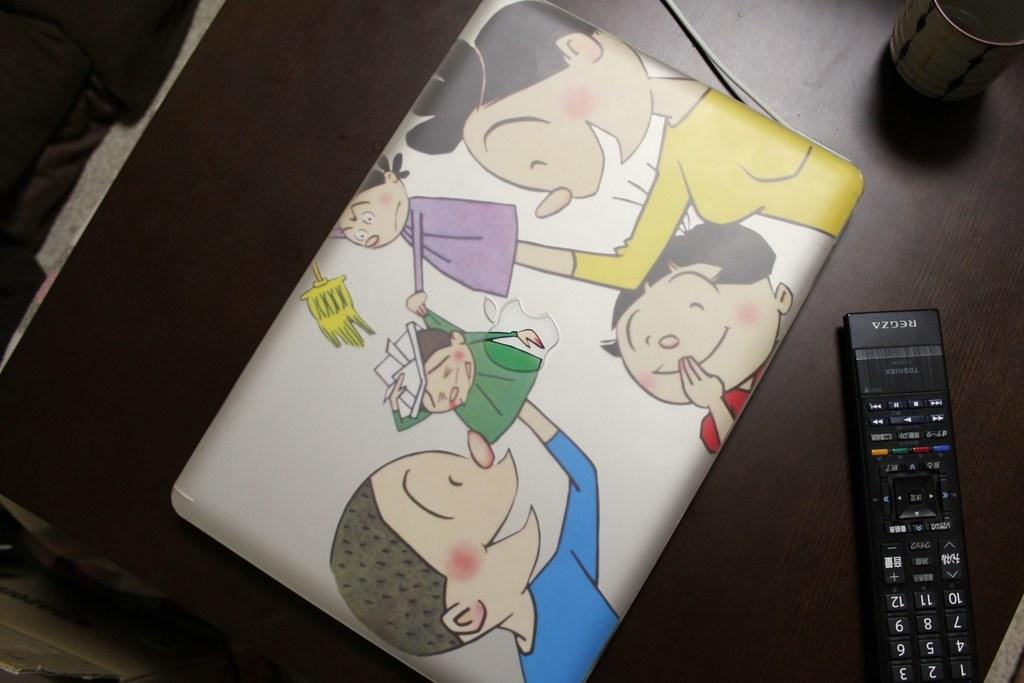<image>
Describe the image concisely. An Apple laptop is on a table by a remote that says Regza. 